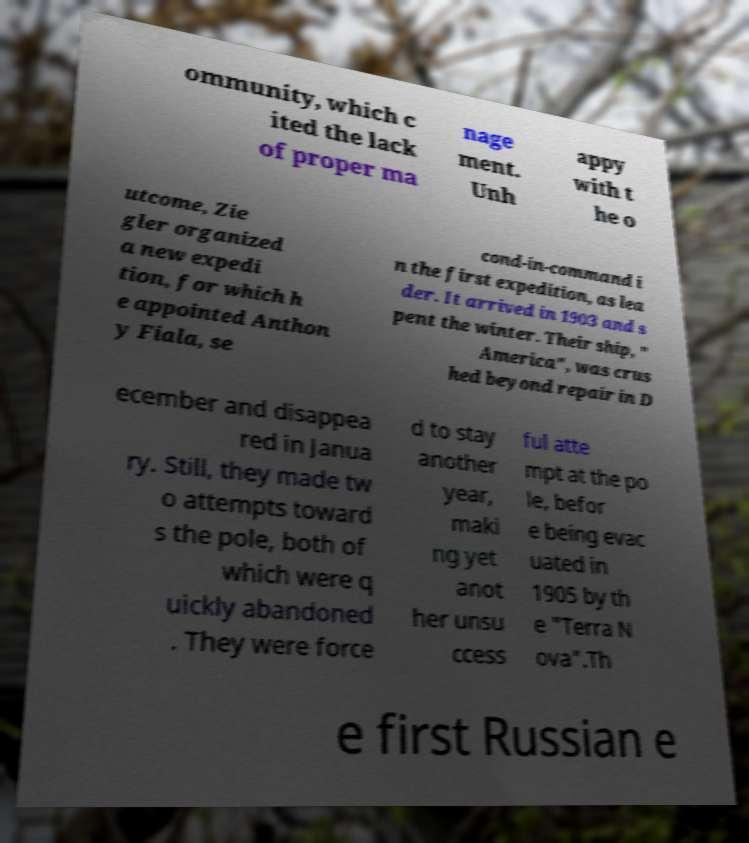Please identify and transcribe the text found in this image. ommunity, which c ited the lack of proper ma nage ment. Unh appy with t he o utcome, Zie gler organized a new expedi tion, for which h e appointed Anthon y Fiala, se cond-in-command i n the first expedition, as lea der. It arrived in 1903 and s pent the winter. Their ship, " America", was crus hed beyond repair in D ecember and disappea red in Janua ry. Still, they made tw o attempts toward s the pole, both of which were q uickly abandoned . They were force d to stay another year, maki ng yet anot her unsu ccess ful atte mpt at the po le, befor e being evac uated in 1905 by th e "Terra N ova".Th e first Russian e 